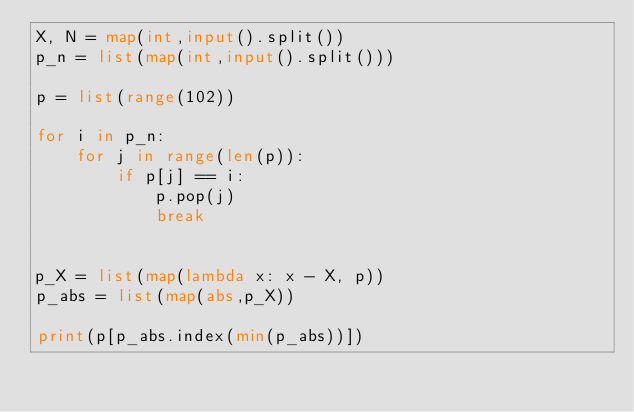<code> <loc_0><loc_0><loc_500><loc_500><_Python_>X, N = map(int,input().split())
p_n = list(map(int,input().split()))

p = list(range(102))

for i in p_n:
    for j in range(len(p)):
        if p[j] == i:
            p.pop(j)
            break
            

p_X = list(map(lambda x: x - X, p))
p_abs = list(map(abs,p_X))

print(p[p_abs.index(min(p_abs))])</code> 